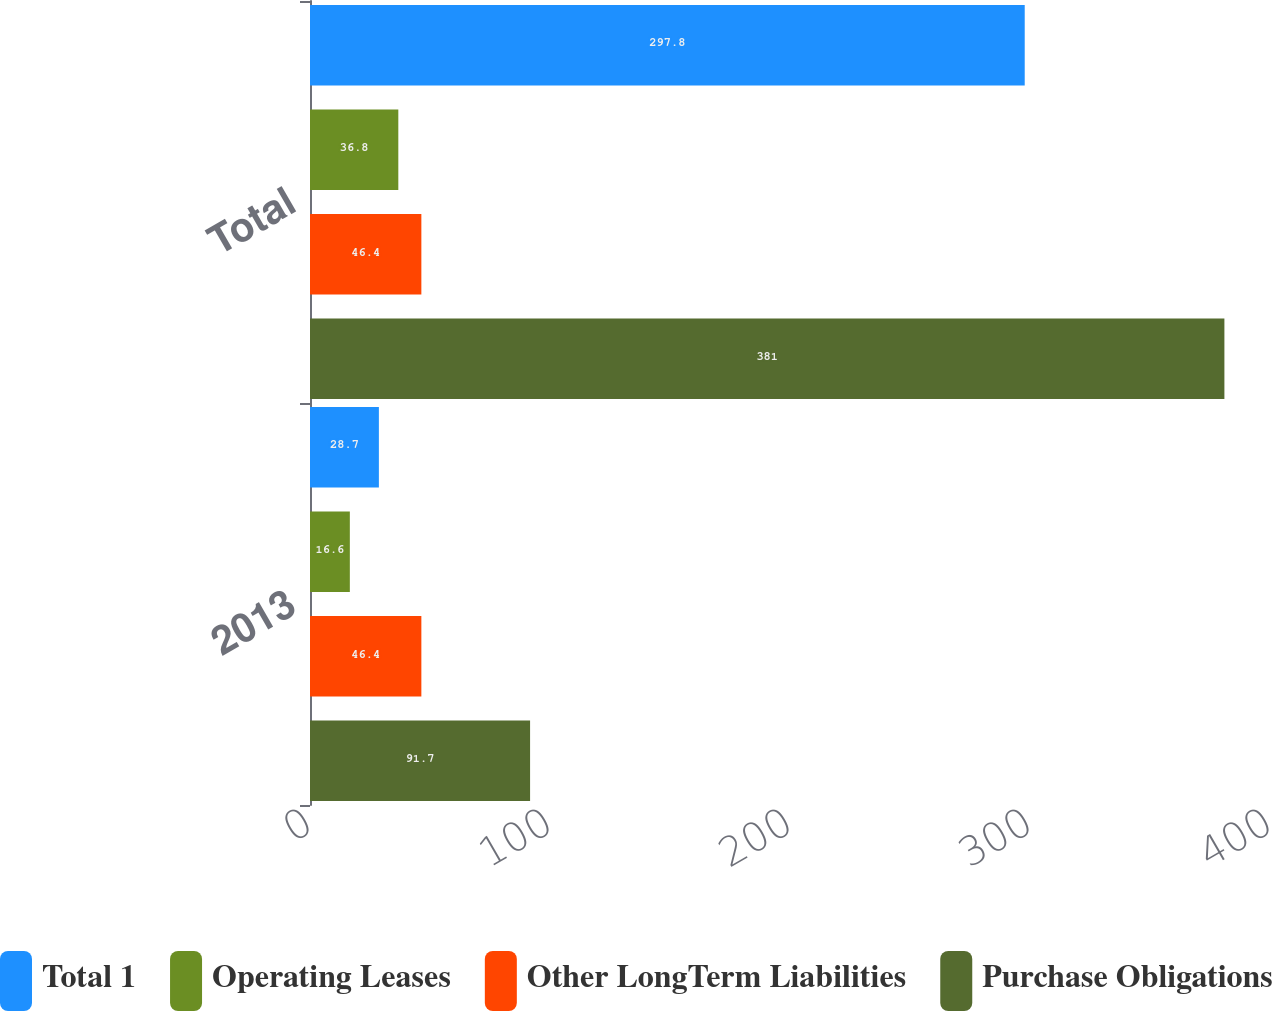Convert chart to OTSL. <chart><loc_0><loc_0><loc_500><loc_500><stacked_bar_chart><ecel><fcel>2013<fcel>Total<nl><fcel>Total 1<fcel>28.7<fcel>297.8<nl><fcel>Operating Leases<fcel>16.6<fcel>36.8<nl><fcel>Other LongTerm Liabilities<fcel>46.4<fcel>46.4<nl><fcel>Purchase Obligations<fcel>91.7<fcel>381<nl></chart> 